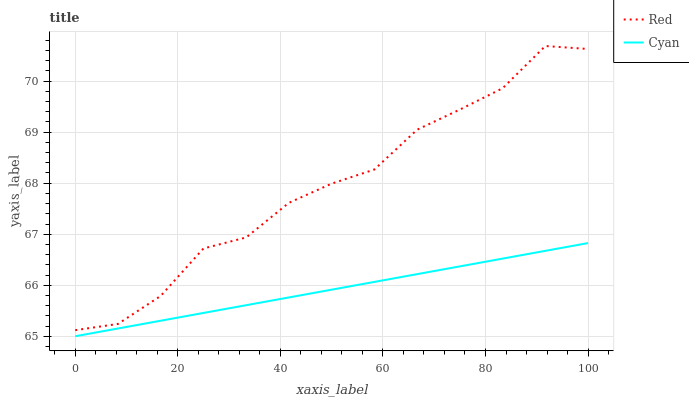Does Cyan have the minimum area under the curve?
Answer yes or no. Yes. Does Red have the maximum area under the curve?
Answer yes or no. Yes. Does Red have the minimum area under the curve?
Answer yes or no. No. Is Cyan the smoothest?
Answer yes or no. Yes. Is Red the roughest?
Answer yes or no. Yes. Is Red the smoothest?
Answer yes or no. No. Does Red have the lowest value?
Answer yes or no. No. Does Red have the highest value?
Answer yes or no. Yes. Is Cyan less than Red?
Answer yes or no. Yes. Is Red greater than Cyan?
Answer yes or no. Yes. Does Cyan intersect Red?
Answer yes or no. No. 